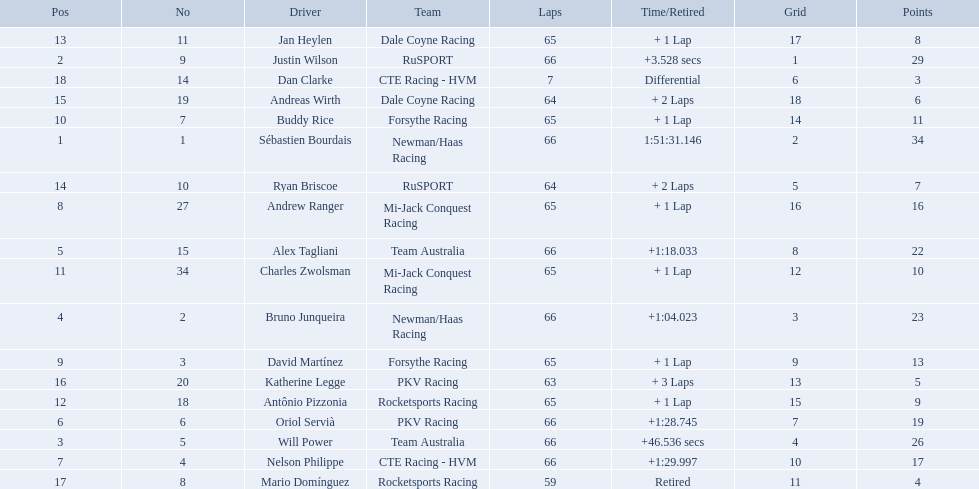What are the names of the drivers who were in position 14 through position 18? Ryan Briscoe, Andreas Wirth, Katherine Legge, Mario Domínguez, Dan Clarke. Of these , which ones didn't finish due to retired or differential? Mario Domínguez, Dan Clarke. Which one of the previous drivers retired? Mario Domínguez. Which of the drivers in question 2 had a differential? Dan Clarke. Which drivers scored at least 10 points? Sébastien Bourdais, Justin Wilson, Will Power, Bruno Junqueira, Alex Tagliani, Oriol Servià, Nelson Philippe, Andrew Ranger, David Martínez, Buddy Rice, Charles Zwolsman. Of those drivers, which ones scored at least 20 points? Sébastien Bourdais, Justin Wilson, Will Power, Bruno Junqueira, Alex Tagliani. Of those 5, which driver scored the most points? Sébastien Bourdais. 